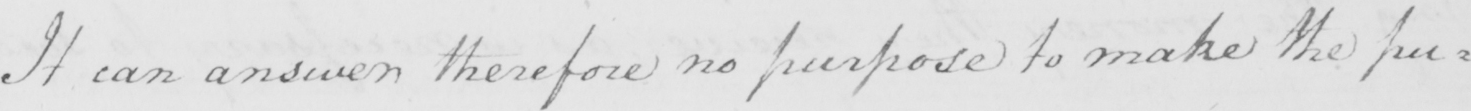Transcribe the text shown in this historical manuscript line. It can answer therefore no purpose to make the pu= 